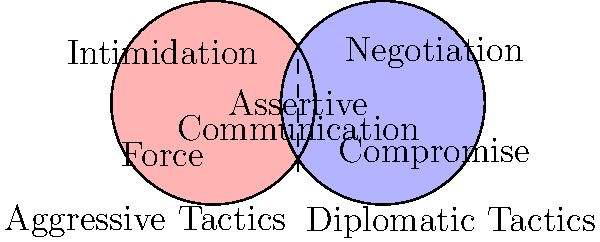Based on the Venn diagram comparing aggressive and diplomatic tactics in field operations, which element is shown in the overlapping area, indicating a characteristic shared by both approaches? To answer this question, let's analyze the Venn diagram step-by-step:

1. The diagram shows two overlapping circles, representing aggressive tactics (left) and diplomatic tactics (right).

2. In the aggressive tactics circle, we see:
   - Intimidation
   - Force

3. In the diplomatic tactics circle, we see:
   - Negotiation
   - Compromise

4. The overlapping area between the two circles represents characteristics shared by both aggressive and diplomatic tactics.

5. In this overlapping area, we can see two elements:
   - Assertive
   - Communication

6. These elements suggest that both aggressive and diplomatic tactics involve assertive communication, although they may differ in the degree and manner of assertiveness.

Therefore, the elements shown in the overlapping area, indicating characteristics shared by both aggressive and diplomatic approaches in field operations, are assertive communication.
Answer: Assertive communication 